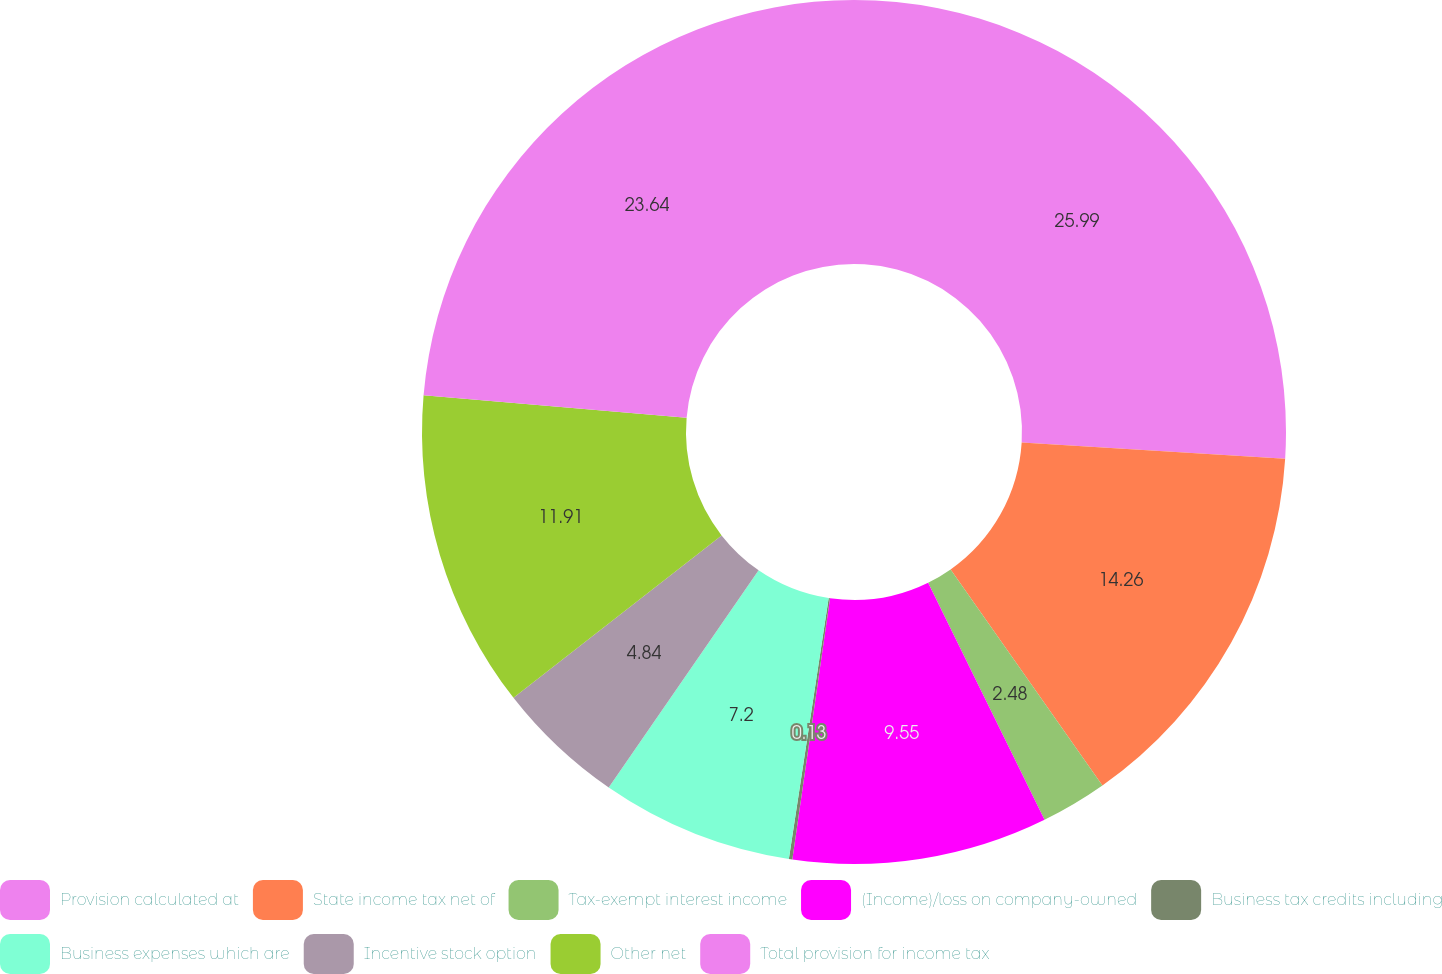Convert chart to OTSL. <chart><loc_0><loc_0><loc_500><loc_500><pie_chart><fcel>Provision calculated at<fcel>State income tax net of<fcel>Tax-exempt interest income<fcel>(Income)/loss on company-owned<fcel>Business tax credits including<fcel>Business expenses which are<fcel>Incentive stock option<fcel>Other net<fcel>Total provision for income tax<nl><fcel>25.99%<fcel>14.26%<fcel>2.48%<fcel>9.55%<fcel>0.13%<fcel>7.2%<fcel>4.84%<fcel>11.91%<fcel>23.64%<nl></chart> 